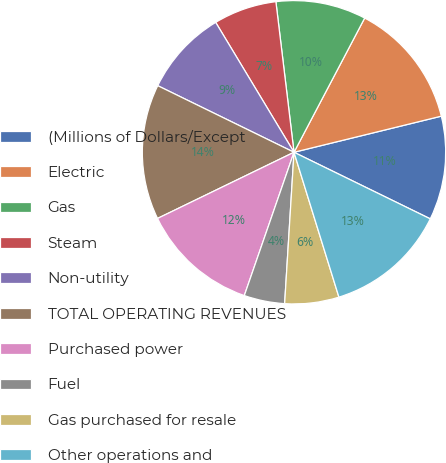Convert chart. <chart><loc_0><loc_0><loc_500><loc_500><pie_chart><fcel>(Millions of Dollars/Except<fcel>Electric<fcel>Gas<fcel>Steam<fcel>Non-utility<fcel>TOTAL OPERATING REVENUES<fcel>Purchased power<fcel>Fuel<fcel>Gas purchased for resale<fcel>Other operations and<nl><fcel>11.06%<fcel>13.46%<fcel>9.62%<fcel>6.73%<fcel>9.13%<fcel>14.42%<fcel>12.5%<fcel>4.33%<fcel>5.77%<fcel>12.98%<nl></chart> 